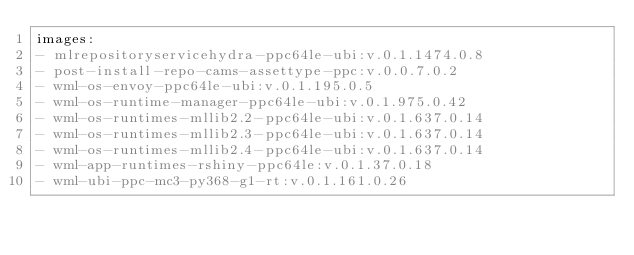<code> <loc_0><loc_0><loc_500><loc_500><_YAML_>images:
- mlrepositoryservicehydra-ppc64le-ubi:v.0.1.1474.0.8
- post-install-repo-cams-assettype-ppc:v.0.0.7.0.2
- wml-os-envoy-ppc64le-ubi:v.0.1.195.0.5
- wml-os-runtime-manager-ppc64le-ubi:v.0.1.975.0.42
- wml-os-runtimes-mllib2.2-ppc64le-ubi:v.0.1.637.0.14
- wml-os-runtimes-mllib2.3-ppc64le-ubi:v.0.1.637.0.14
- wml-os-runtimes-mllib2.4-ppc64le-ubi:v.0.1.637.0.14
- wml-app-runtimes-rshiny-ppc64le:v.0.1.37.0.18
- wml-ubi-ppc-mc3-py368-g1-rt:v.0.1.161.0.26</code> 